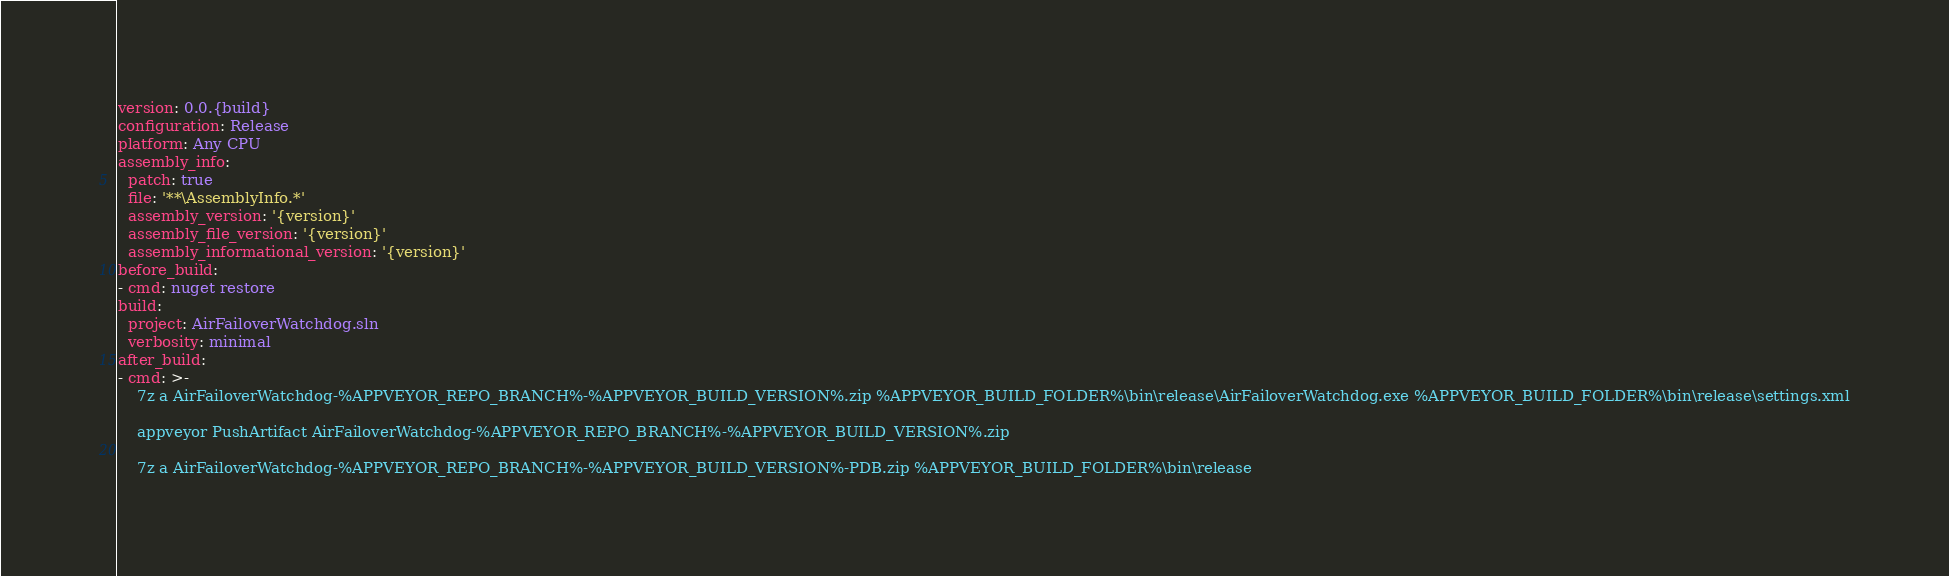<code> <loc_0><loc_0><loc_500><loc_500><_YAML_>version: 0.0.{build}
configuration: Release
platform: Any CPU
assembly_info:
  patch: true
  file: '**\AssemblyInfo.*'
  assembly_version: '{version}'
  assembly_file_version: '{version}'
  assembly_informational_version: '{version}'
before_build:
- cmd: nuget restore
build:
  project: AirFailoverWatchdog.sln
  verbosity: minimal
after_build:
- cmd: >-
    7z a AirFailoverWatchdog-%APPVEYOR_REPO_BRANCH%-%APPVEYOR_BUILD_VERSION%.zip %APPVEYOR_BUILD_FOLDER%\bin\release\AirFailoverWatchdog.exe %APPVEYOR_BUILD_FOLDER%\bin\release\settings.xml

    appveyor PushArtifact AirFailoverWatchdog-%APPVEYOR_REPO_BRANCH%-%APPVEYOR_BUILD_VERSION%.zip
    
    7z a AirFailoverWatchdog-%APPVEYOR_REPO_BRANCH%-%APPVEYOR_BUILD_VERSION%-PDB.zip %APPVEYOR_BUILD_FOLDER%\bin\release
</code> 